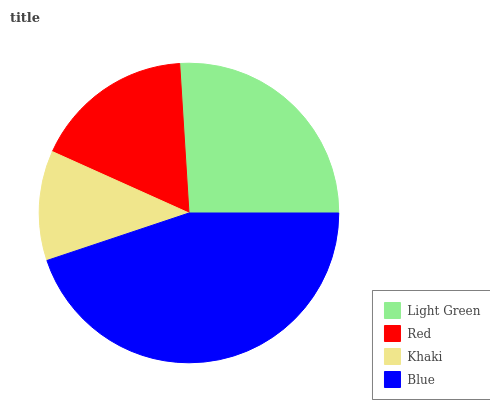Is Khaki the minimum?
Answer yes or no. Yes. Is Blue the maximum?
Answer yes or no. Yes. Is Red the minimum?
Answer yes or no. No. Is Red the maximum?
Answer yes or no. No. Is Light Green greater than Red?
Answer yes or no. Yes. Is Red less than Light Green?
Answer yes or no. Yes. Is Red greater than Light Green?
Answer yes or no. No. Is Light Green less than Red?
Answer yes or no. No. Is Light Green the high median?
Answer yes or no. Yes. Is Red the low median?
Answer yes or no. Yes. Is Blue the high median?
Answer yes or no. No. Is Light Green the low median?
Answer yes or no. No. 